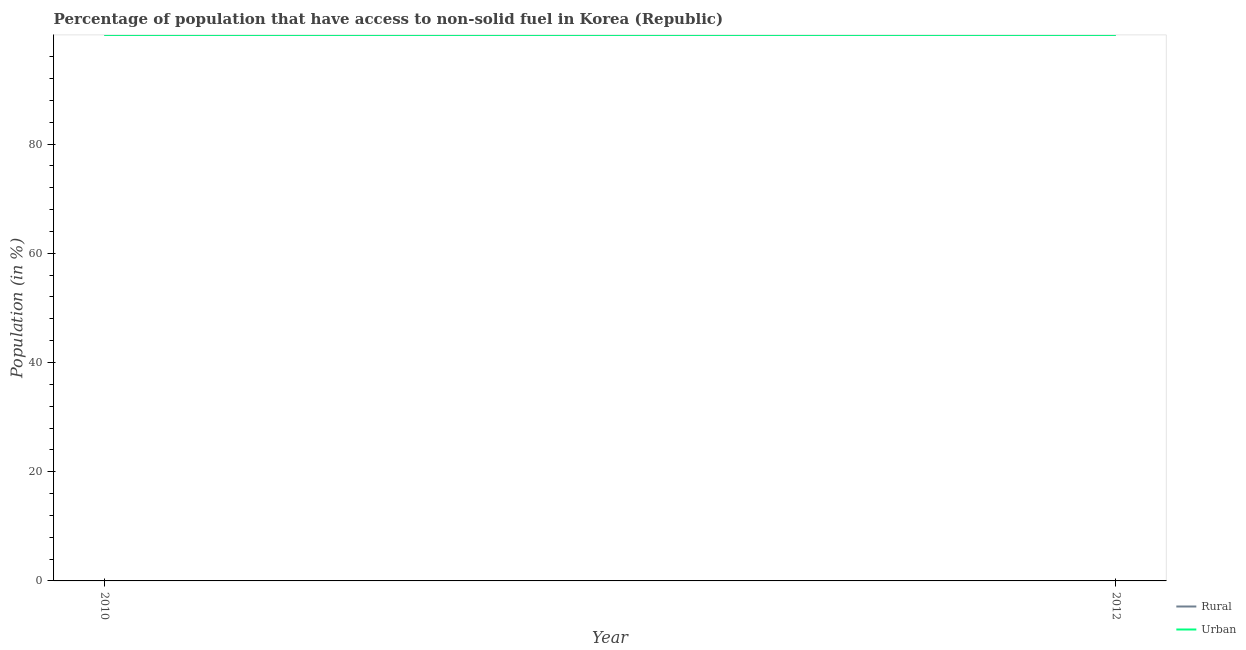How many different coloured lines are there?
Your response must be concise. 2. What is the urban population in 2012?
Your response must be concise. 99.99. Across all years, what is the maximum rural population?
Provide a short and direct response. 99.99. Across all years, what is the minimum rural population?
Provide a succinct answer. 99.99. In which year was the urban population minimum?
Provide a succinct answer. 2012. What is the total urban population in the graph?
Provide a succinct answer. 199.98. What is the average rural population per year?
Your answer should be very brief. 99.99. In the year 2012, what is the difference between the urban population and rural population?
Provide a succinct answer. 0. In how many years, is the urban population greater than 32 %?
Ensure brevity in your answer.  2. Is the urban population in 2010 less than that in 2012?
Give a very brief answer. No. In how many years, is the rural population greater than the average rural population taken over all years?
Ensure brevity in your answer.  0. Is the rural population strictly less than the urban population over the years?
Make the answer very short. No. How many lines are there?
Provide a short and direct response. 2. Does the graph contain any zero values?
Offer a very short reply. No. Does the graph contain grids?
Give a very brief answer. No. How many legend labels are there?
Provide a short and direct response. 2. How are the legend labels stacked?
Ensure brevity in your answer.  Vertical. What is the title of the graph?
Offer a terse response. Percentage of population that have access to non-solid fuel in Korea (Republic). What is the Population (in %) of Rural in 2010?
Offer a very short reply. 99.99. What is the Population (in %) of Urban in 2010?
Your answer should be very brief. 99.99. What is the Population (in %) in Rural in 2012?
Provide a short and direct response. 99.99. What is the Population (in %) in Urban in 2012?
Offer a very short reply. 99.99. Across all years, what is the maximum Population (in %) in Rural?
Your response must be concise. 99.99. Across all years, what is the maximum Population (in %) in Urban?
Keep it short and to the point. 99.99. Across all years, what is the minimum Population (in %) in Rural?
Your answer should be very brief. 99.99. Across all years, what is the minimum Population (in %) of Urban?
Provide a short and direct response. 99.99. What is the total Population (in %) in Rural in the graph?
Give a very brief answer. 199.98. What is the total Population (in %) in Urban in the graph?
Your response must be concise. 199.98. What is the difference between the Population (in %) in Rural in 2010 and that in 2012?
Your answer should be very brief. 0. What is the difference between the Population (in %) of Urban in 2010 and that in 2012?
Your response must be concise. 0. What is the average Population (in %) in Rural per year?
Provide a short and direct response. 99.99. What is the average Population (in %) in Urban per year?
Make the answer very short. 99.99. What is the ratio of the Population (in %) in Rural in 2010 to that in 2012?
Your answer should be compact. 1. What is the difference between the highest and the lowest Population (in %) in Rural?
Make the answer very short. 0. 